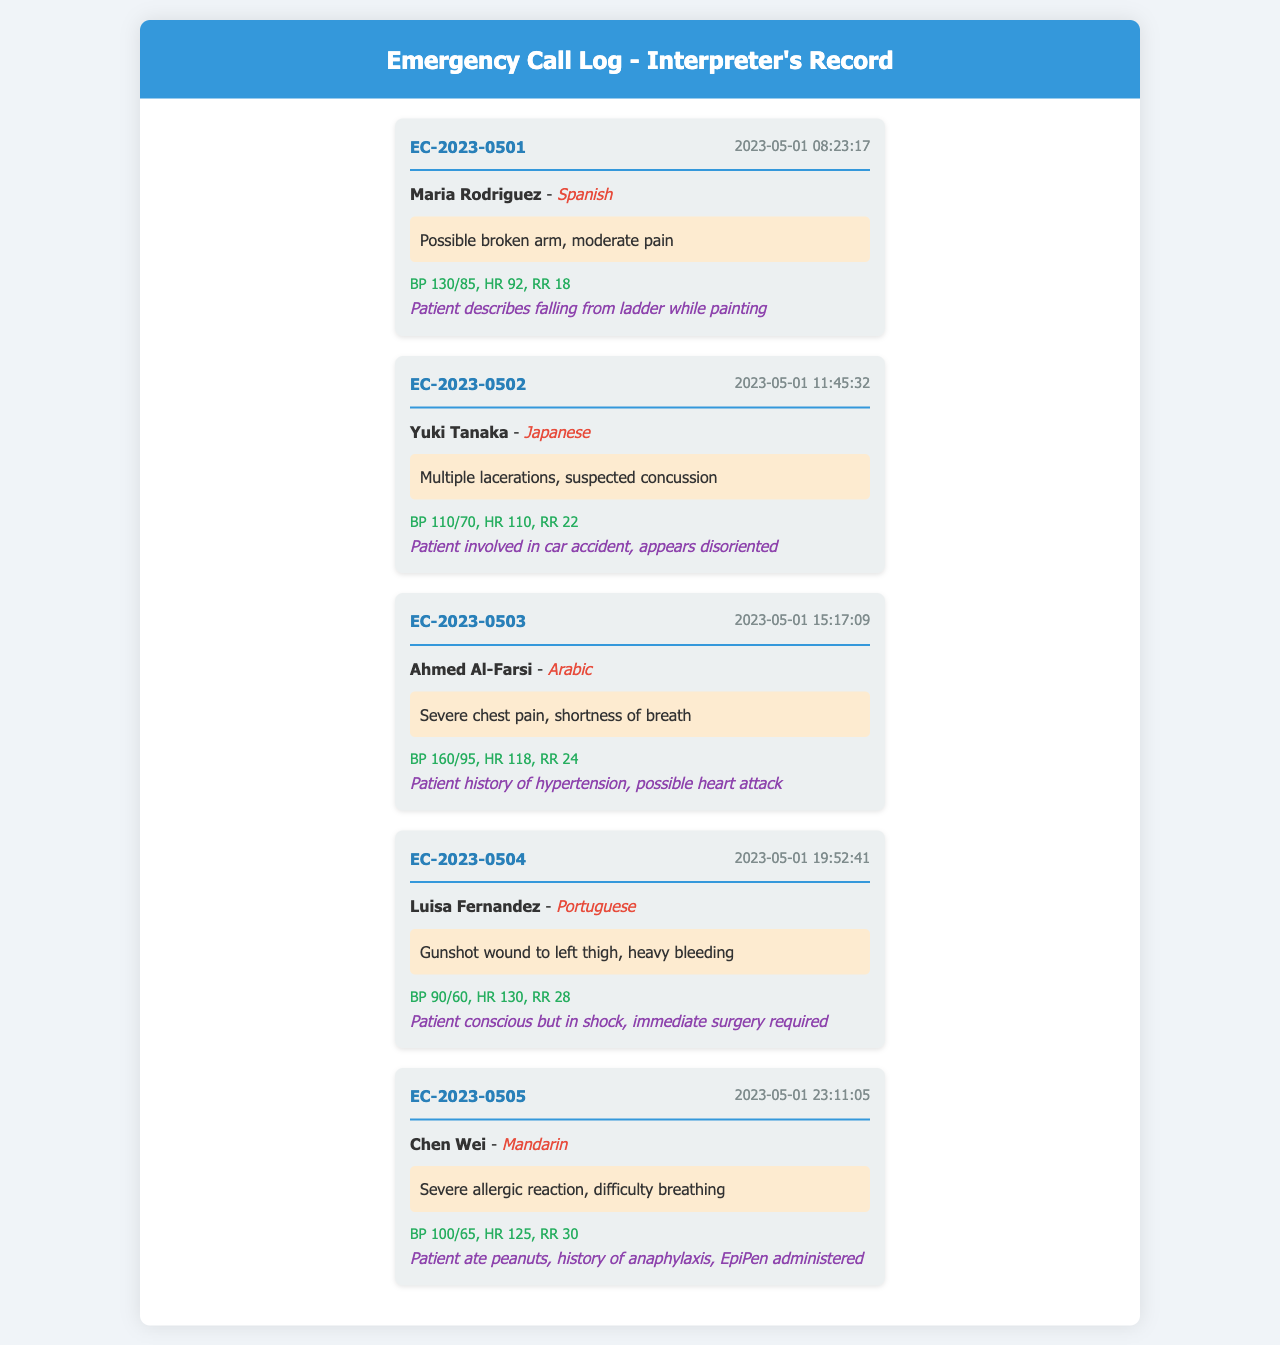What is the name of the first patient? The first patient listed in the document is Maria Rodriguez.
Answer: Maria Rodriguez What language does Yuki Tanaka speak? Yuki Tanaka's language is indicated as Japanese in the document.
Answer: Japanese What is the timestamp of the call involving Luisa Fernandez? The timestamp for Luisa Fernandez's call is found in the call entry details, which is 2023-05-01 19:52:41.
Answer: 2023-05-01 19:52:41 How many patients had a blood pressure reading below 100? By reviewing the vital signs, Luisa Fernandez had BP 90/60, which is below 100.
Answer: 1 What is Ahmed Al-Farsi's assessment? The assessment for Ahmed Al-Farsi states "Severe chest pain, shortness of breath."
Answer: Severe chest pain, shortness of breath Which patient required immediate surgery? The entry for Luisa Fernandez indicates that she required immediate surgery.
Answer: Luisa Fernandez What was Chen Wei's reported vital sign for heart rate? Chen Wei's heart rate was recorded as HR 125 in the vital signs provided.
Answer: HR 125 How many lacerations did Yuki Tanaka have? The assessment for Yuki Tanaka mentions "Multiple lacerations," which is the total count.
Answer: Multiple lacerations What injury did Maria Rodriguez sustain? According to the assessment, Maria Rodriguez possibly has a broken arm.
Answer: Possibly broken arm 